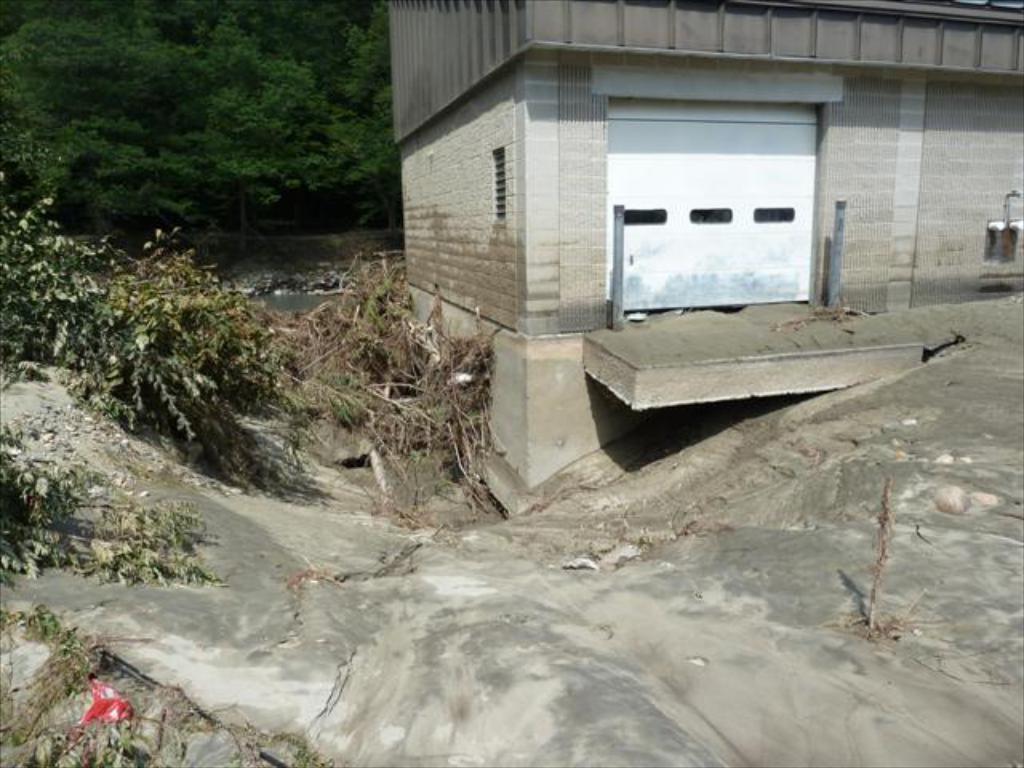Can you describe this image briefly? On the right we can see the building. On the left we can see water near to the plant. In the top right there is a white door near to the pipes. At the bottom we can see the clay. In the background we can see many trees. 